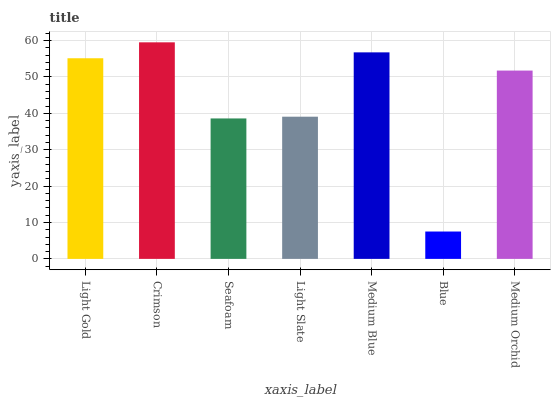Is Blue the minimum?
Answer yes or no. Yes. Is Crimson the maximum?
Answer yes or no. Yes. Is Seafoam the minimum?
Answer yes or no. No. Is Seafoam the maximum?
Answer yes or no. No. Is Crimson greater than Seafoam?
Answer yes or no. Yes. Is Seafoam less than Crimson?
Answer yes or no. Yes. Is Seafoam greater than Crimson?
Answer yes or no. No. Is Crimson less than Seafoam?
Answer yes or no. No. Is Medium Orchid the high median?
Answer yes or no. Yes. Is Medium Orchid the low median?
Answer yes or no. Yes. Is Seafoam the high median?
Answer yes or no. No. Is Blue the low median?
Answer yes or no. No. 